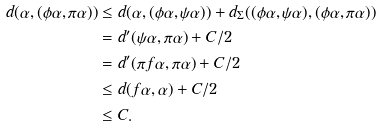Convert formula to latex. <formula><loc_0><loc_0><loc_500><loc_500>d ( \alpha , ( \phi \alpha , \pi \alpha ) ) & \leq d ( \alpha , ( \phi \alpha , \psi \alpha ) ) + d _ { \Sigma } ( ( \phi \alpha , \psi \alpha ) , ( \phi \alpha , \pi \alpha ) ) \\ & = d ^ { \prime } ( \psi \alpha , \pi \alpha ) + C / 2 \\ & = d ^ { \prime } ( \pi f \alpha , \pi \alpha ) + C / 2 \\ & \leq d ( f \alpha , \alpha ) + C / 2 \\ & \leq C .</formula> 